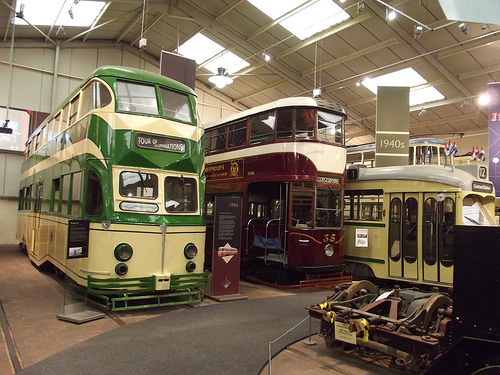<image>
Can you confirm if the window is above the bus? Yes. The window is positioned above the bus in the vertical space, higher up in the scene. 